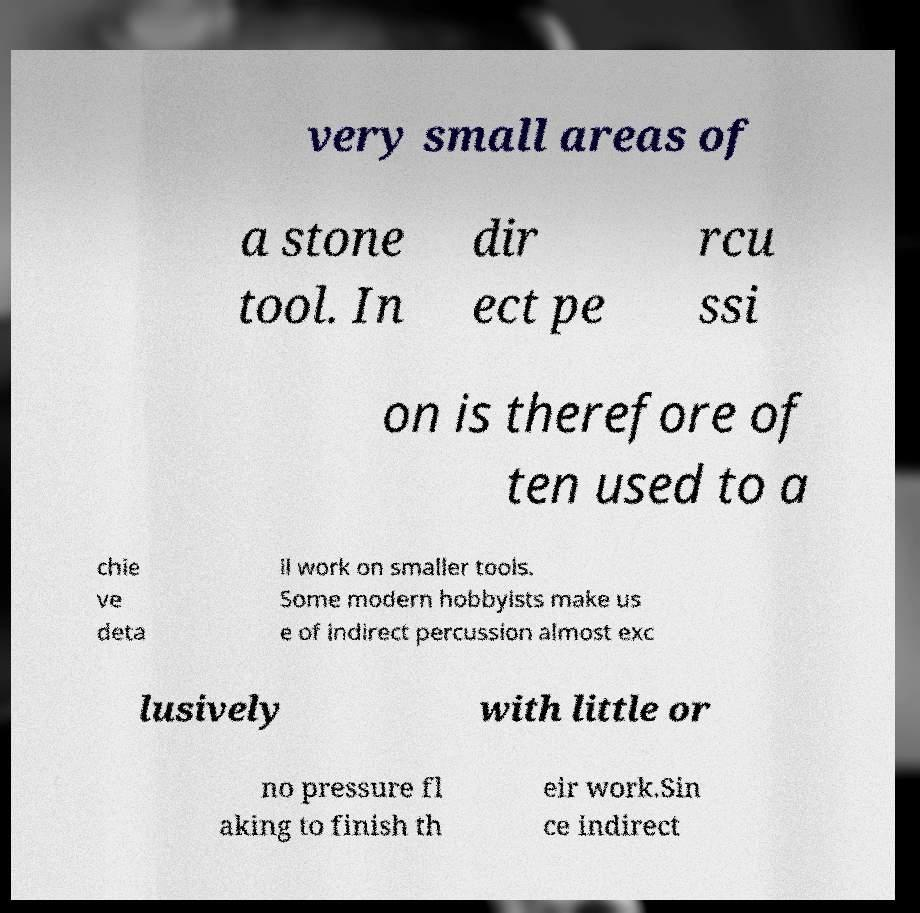There's text embedded in this image that I need extracted. Can you transcribe it verbatim? very small areas of a stone tool. In dir ect pe rcu ssi on is therefore of ten used to a chie ve deta il work on smaller tools. Some modern hobbyists make us e of indirect percussion almost exc lusively with little or no pressure fl aking to finish th eir work.Sin ce indirect 